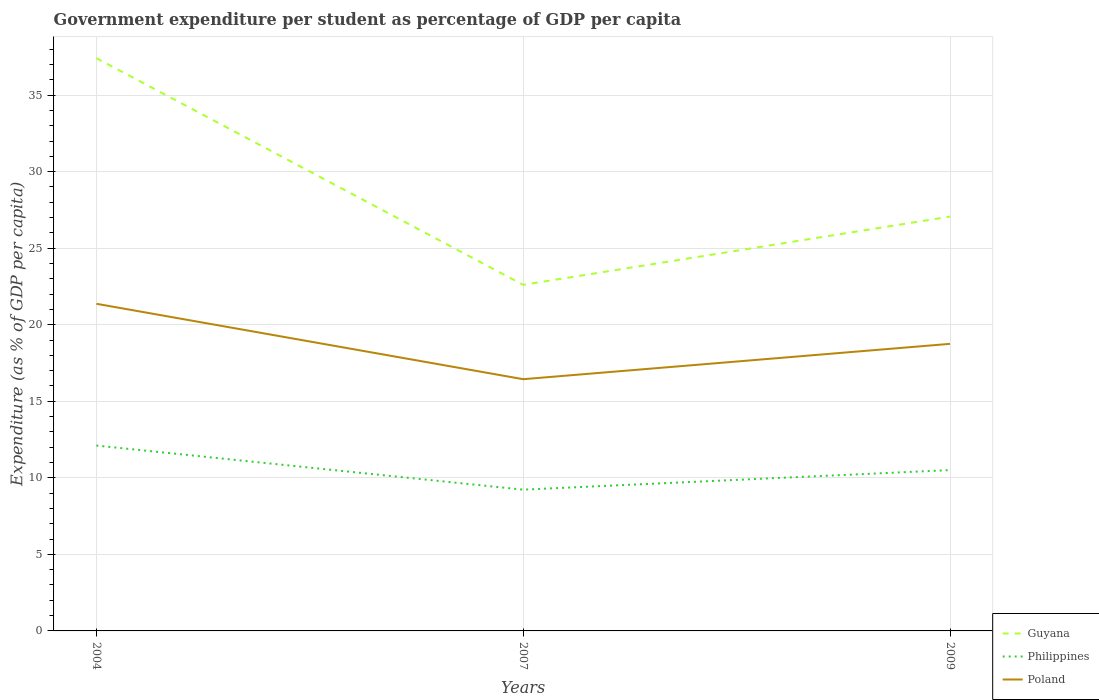How many different coloured lines are there?
Give a very brief answer. 3. Is the number of lines equal to the number of legend labels?
Keep it short and to the point. Yes. Across all years, what is the maximum percentage of expenditure per student in Poland?
Offer a very short reply. 16.44. In which year was the percentage of expenditure per student in Poland maximum?
Your answer should be very brief. 2007. What is the total percentage of expenditure per student in Poland in the graph?
Your response must be concise. 4.93. What is the difference between the highest and the second highest percentage of expenditure per student in Poland?
Offer a very short reply. 4.93. What is the difference between the highest and the lowest percentage of expenditure per student in Philippines?
Keep it short and to the point. 1. How many years are there in the graph?
Keep it short and to the point. 3. What is the difference between two consecutive major ticks on the Y-axis?
Your answer should be compact. 5. Are the values on the major ticks of Y-axis written in scientific E-notation?
Offer a very short reply. No. Does the graph contain any zero values?
Your answer should be compact. No. What is the title of the graph?
Keep it short and to the point. Government expenditure per student as percentage of GDP per capita. What is the label or title of the X-axis?
Give a very brief answer. Years. What is the label or title of the Y-axis?
Offer a very short reply. Expenditure (as % of GDP per capita). What is the Expenditure (as % of GDP per capita) of Guyana in 2004?
Your response must be concise. 37.41. What is the Expenditure (as % of GDP per capita) in Philippines in 2004?
Keep it short and to the point. 12.11. What is the Expenditure (as % of GDP per capita) of Poland in 2004?
Your answer should be compact. 21.37. What is the Expenditure (as % of GDP per capita) in Guyana in 2007?
Offer a terse response. 22.61. What is the Expenditure (as % of GDP per capita) of Philippines in 2007?
Your answer should be very brief. 9.23. What is the Expenditure (as % of GDP per capita) in Poland in 2007?
Your answer should be compact. 16.44. What is the Expenditure (as % of GDP per capita) in Guyana in 2009?
Offer a terse response. 27.06. What is the Expenditure (as % of GDP per capita) of Philippines in 2009?
Provide a succinct answer. 10.51. What is the Expenditure (as % of GDP per capita) of Poland in 2009?
Offer a terse response. 18.75. Across all years, what is the maximum Expenditure (as % of GDP per capita) of Guyana?
Ensure brevity in your answer.  37.41. Across all years, what is the maximum Expenditure (as % of GDP per capita) of Philippines?
Provide a short and direct response. 12.11. Across all years, what is the maximum Expenditure (as % of GDP per capita) of Poland?
Provide a succinct answer. 21.37. Across all years, what is the minimum Expenditure (as % of GDP per capita) of Guyana?
Offer a terse response. 22.61. Across all years, what is the minimum Expenditure (as % of GDP per capita) of Philippines?
Your response must be concise. 9.23. Across all years, what is the minimum Expenditure (as % of GDP per capita) in Poland?
Keep it short and to the point. 16.44. What is the total Expenditure (as % of GDP per capita) of Guyana in the graph?
Offer a terse response. 87.09. What is the total Expenditure (as % of GDP per capita) of Philippines in the graph?
Keep it short and to the point. 31.84. What is the total Expenditure (as % of GDP per capita) in Poland in the graph?
Give a very brief answer. 56.56. What is the difference between the Expenditure (as % of GDP per capita) in Guyana in 2004 and that in 2007?
Offer a terse response. 14.81. What is the difference between the Expenditure (as % of GDP per capita) in Philippines in 2004 and that in 2007?
Ensure brevity in your answer.  2.88. What is the difference between the Expenditure (as % of GDP per capita) of Poland in 2004 and that in 2007?
Make the answer very short. 4.93. What is the difference between the Expenditure (as % of GDP per capita) of Guyana in 2004 and that in 2009?
Provide a succinct answer. 10.35. What is the difference between the Expenditure (as % of GDP per capita) of Philippines in 2004 and that in 2009?
Your response must be concise. 1.6. What is the difference between the Expenditure (as % of GDP per capita) of Poland in 2004 and that in 2009?
Offer a terse response. 2.62. What is the difference between the Expenditure (as % of GDP per capita) in Guyana in 2007 and that in 2009?
Make the answer very short. -4.46. What is the difference between the Expenditure (as % of GDP per capita) in Philippines in 2007 and that in 2009?
Ensure brevity in your answer.  -1.28. What is the difference between the Expenditure (as % of GDP per capita) of Poland in 2007 and that in 2009?
Make the answer very short. -2.31. What is the difference between the Expenditure (as % of GDP per capita) in Guyana in 2004 and the Expenditure (as % of GDP per capita) in Philippines in 2007?
Keep it short and to the point. 28.19. What is the difference between the Expenditure (as % of GDP per capita) in Guyana in 2004 and the Expenditure (as % of GDP per capita) in Poland in 2007?
Ensure brevity in your answer.  20.97. What is the difference between the Expenditure (as % of GDP per capita) in Philippines in 2004 and the Expenditure (as % of GDP per capita) in Poland in 2007?
Offer a very short reply. -4.33. What is the difference between the Expenditure (as % of GDP per capita) in Guyana in 2004 and the Expenditure (as % of GDP per capita) in Philippines in 2009?
Keep it short and to the point. 26.91. What is the difference between the Expenditure (as % of GDP per capita) in Guyana in 2004 and the Expenditure (as % of GDP per capita) in Poland in 2009?
Ensure brevity in your answer.  18.66. What is the difference between the Expenditure (as % of GDP per capita) in Philippines in 2004 and the Expenditure (as % of GDP per capita) in Poland in 2009?
Offer a very short reply. -6.64. What is the difference between the Expenditure (as % of GDP per capita) in Guyana in 2007 and the Expenditure (as % of GDP per capita) in Poland in 2009?
Ensure brevity in your answer.  3.85. What is the difference between the Expenditure (as % of GDP per capita) of Philippines in 2007 and the Expenditure (as % of GDP per capita) of Poland in 2009?
Offer a very short reply. -9.52. What is the average Expenditure (as % of GDP per capita) of Guyana per year?
Keep it short and to the point. 29.03. What is the average Expenditure (as % of GDP per capita) of Philippines per year?
Your answer should be compact. 10.61. What is the average Expenditure (as % of GDP per capita) in Poland per year?
Your response must be concise. 18.85. In the year 2004, what is the difference between the Expenditure (as % of GDP per capita) of Guyana and Expenditure (as % of GDP per capita) of Philippines?
Your response must be concise. 25.31. In the year 2004, what is the difference between the Expenditure (as % of GDP per capita) in Guyana and Expenditure (as % of GDP per capita) in Poland?
Ensure brevity in your answer.  16.05. In the year 2004, what is the difference between the Expenditure (as % of GDP per capita) in Philippines and Expenditure (as % of GDP per capita) in Poland?
Offer a terse response. -9.26. In the year 2007, what is the difference between the Expenditure (as % of GDP per capita) in Guyana and Expenditure (as % of GDP per capita) in Philippines?
Your response must be concise. 13.38. In the year 2007, what is the difference between the Expenditure (as % of GDP per capita) in Guyana and Expenditure (as % of GDP per capita) in Poland?
Provide a short and direct response. 6.16. In the year 2007, what is the difference between the Expenditure (as % of GDP per capita) of Philippines and Expenditure (as % of GDP per capita) of Poland?
Your answer should be very brief. -7.22. In the year 2009, what is the difference between the Expenditure (as % of GDP per capita) in Guyana and Expenditure (as % of GDP per capita) in Philippines?
Give a very brief answer. 16.56. In the year 2009, what is the difference between the Expenditure (as % of GDP per capita) of Guyana and Expenditure (as % of GDP per capita) of Poland?
Give a very brief answer. 8.31. In the year 2009, what is the difference between the Expenditure (as % of GDP per capita) of Philippines and Expenditure (as % of GDP per capita) of Poland?
Offer a very short reply. -8.25. What is the ratio of the Expenditure (as % of GDP per capita) of Guyana in 2004 to that in 2007?
Your response must be concise. 1.66. What is the ratio of the Expenditure (as % of GDP per capita) in Philippines in 2004 to that in 2007?
Provide a succinct answer. 1.31. What is the ratio of the Expenditure (as % of GDP per capita) of Poland in 2004 to that in 2007?
Your response must be concise. 1.3. What is the ratio of the Expenditure (as % of GDP per capita) in Guyana in 2004 to that in 2009?
Keep it short and to the point. 1.38. What is the ratio of the Expenditure (as % of GDP per capita) of Philippines in 2004 to that in 2009?
Offer a very short reply. 1.15. What is the ratio of the Expenditure (as % of GDP per capita) in Poland in 2004 to that in 2009?
Provide a succinct answer. 1.14. What is the ratio of the Expenditure (as % of GDP per capita) of Guyana in 2007 to that in 2009?
Ensure brevity in your answer.  0.84. What is the ratio of the Expenditure (as % of GDP per capita) of Philippines in 2007 to that in 2009?
Your answer should be very brief. 0.88. What is the ratio of the Expenditure (as % of GDP per capita) of Poland in 2007 to that in 2009?
Offer a terse response. 0.88. What is the difference between the highest and the second highest Expenditure (as % of GDP per capita) in Guyana?
Provide a succinct answer. 10.35. What is the difference between the highest and the second highest Expenditure (as % of GDP per capita) of Philippines?
Provide a short and direct response. 1.6. What is the difference between the highest and the second highest Expenditure (as % of GDP per capita) of Poland?
Your answer should be very brief. 2.62. What is the difference between the highest and the lowest Expenditure (as % of GDP per capita) in Guyana?
Ensure brevity in your answer.  14.81. What is the difference between the highest and the lowest Expenditure (as % of GDP per capita) of Philippines?
Your answer should be very brief. 2.88. What is the difference between the highest and the lowest Expenditure (as % of GDP per capita) of Poland?
Offer a very short reply. 4.93. 